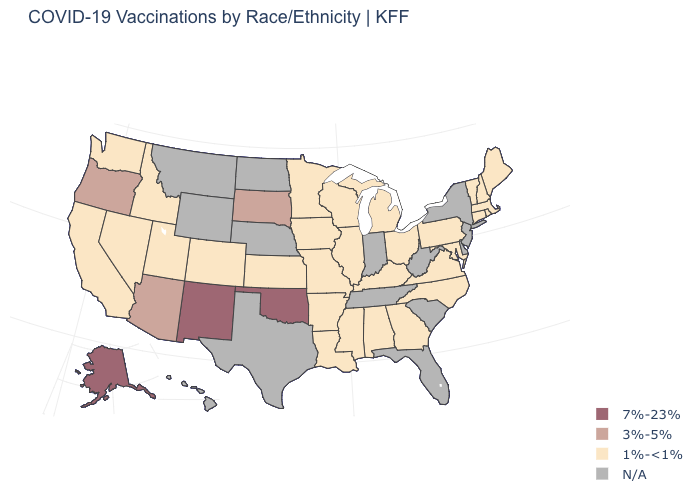Does the map have missing data?
Quick response, please. Yes. What is the value of New Hampshire?
Keep it brief. 1%-<1%. What is the value of Maryland?
Answer briefly. 1%-<1%. What is the lowest value in states that border Massachusetts?
Concise answer only. 1%-<1%. Which states have the highest value in the USA?
Give a very brief answer. Alaska, New Mexico, Oklahoma. Does California have the lowest value in the West?
Keep it brief. Yes. Among the states that border West Virginia , which have the lowest value?
Quick response, please. Kentucky, Maryland, Ohio, Pennsylvania, Virginia. What is the value of Nebraska?
Be succinct. N/A. Which states hav the highest value in the West?
Give a very brief answer. Alaska, New Mexico. What is the value of Colorado?
Be succinct. 1%-<1%. What is the value of Delaware?
Keep it brief. N/A. What is the value of Wyoming?
Quick response, please. N/A. What is the value of Hawaii?
Keep it brief. N/A. What is the lowest value in the USA?
Give a very brief answer. 1%-<1%. What is the highest value in the USA?
Be succinct. 7%-23%. 